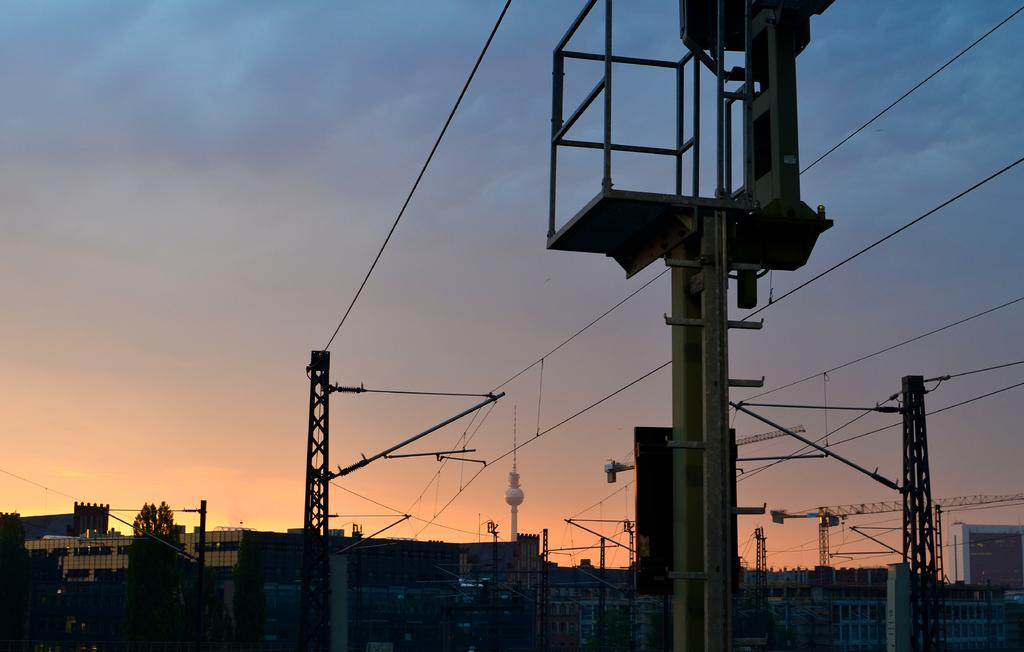What type of structures can be seen in the image? There are current poles and buildings visible in the image. How are the current poles arranged in the image? The current poles are arranged with buildings between them. What type of vegetation is on the left side of the image? There are trees on the left side of the image. What type of screw can be seen holding the buildings together in the image? There are no screws visible in the image; the buildings are not shown to be held together by any visible fasteners. 